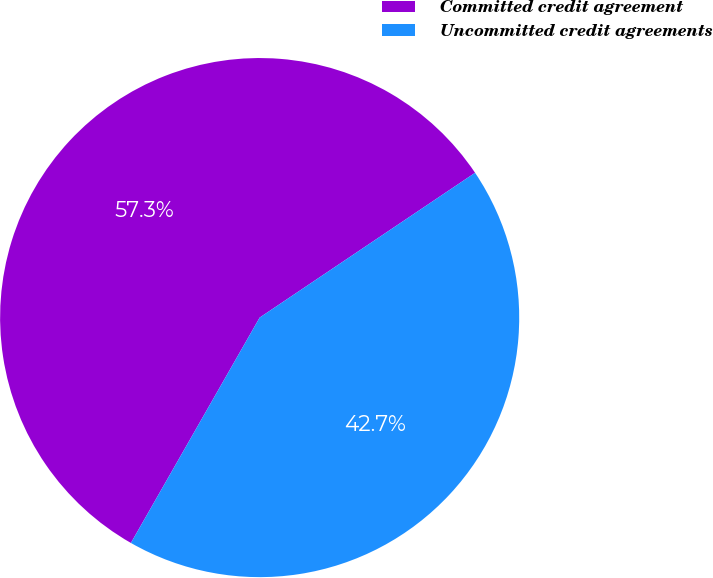Convert chart to OTSL. <chart><loc_0><loc_0><loc_500><loc_500><pie_chart><fcel>Committed credit agreement<fcel>Uncommitted credit agreements<nl><fcel>57.32%<fcel>42.68%<nl></chart> 